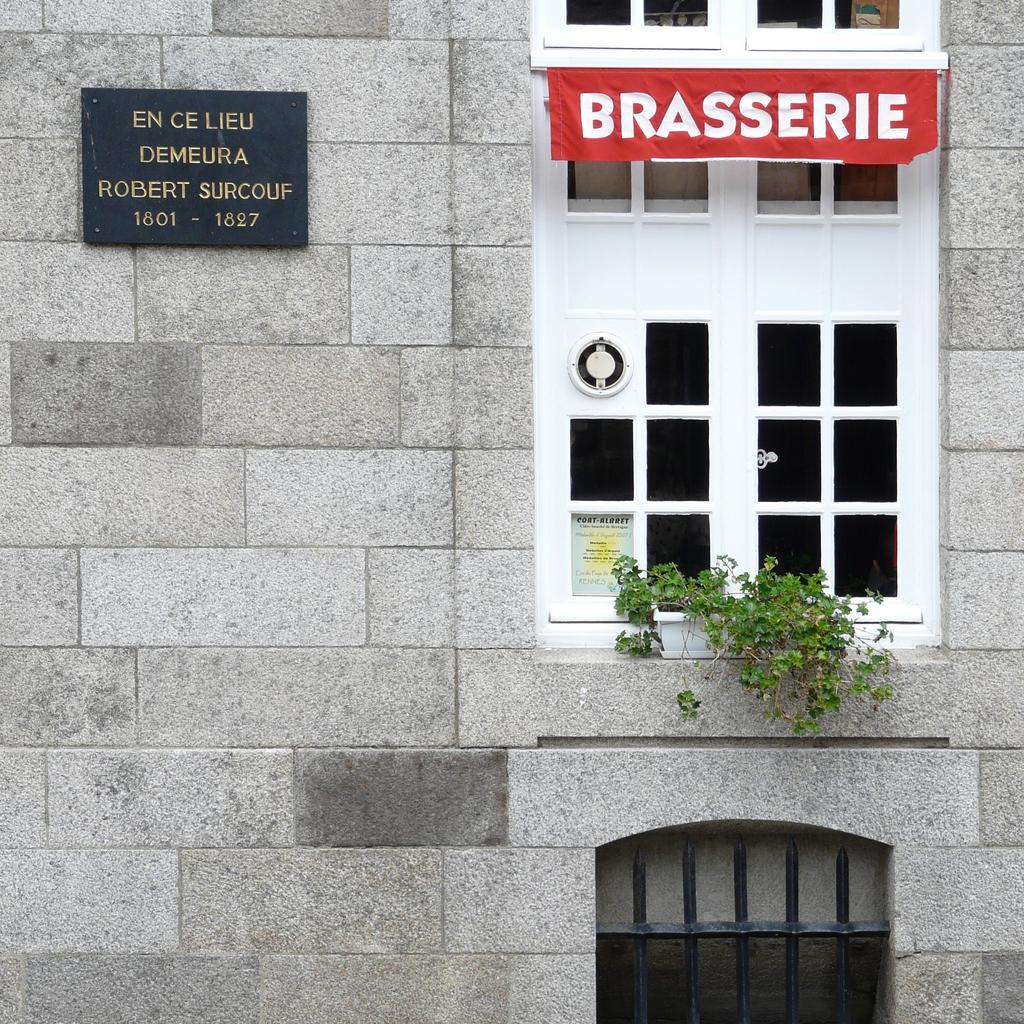Please provide a concise description of this image. In this image we can see the wall of a building. There are few windows in the image. We can see a plant in the image. We can see some text on the boards in the image. 